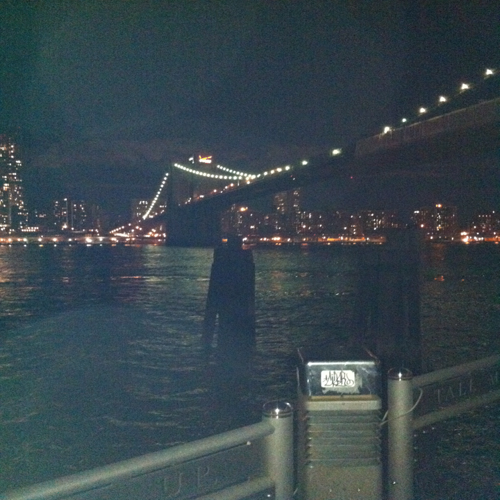What might be the significance of the structure shown in the image? The structure depicted is a bridge that appears to be a significant connector between two land masses. Bridges like this often represent engineering marvels and serve as critical infrastructure for transportation. Additionally, the bridge may be a historic landmark or a symbol of the city, playing a role in both its functional needs and cultural identity. What do you think is the perspective of the person taking the photo? The photographer's perspective seems to be from a waterfront or shoreline, taking the photo from a lower angle looking up at the expanse of the bridge. This vantage point allows viewers to appreciate the scale of the bridge and its role within the cityscape, suggesting admiration or highlighting the structure's dominance in the view. 